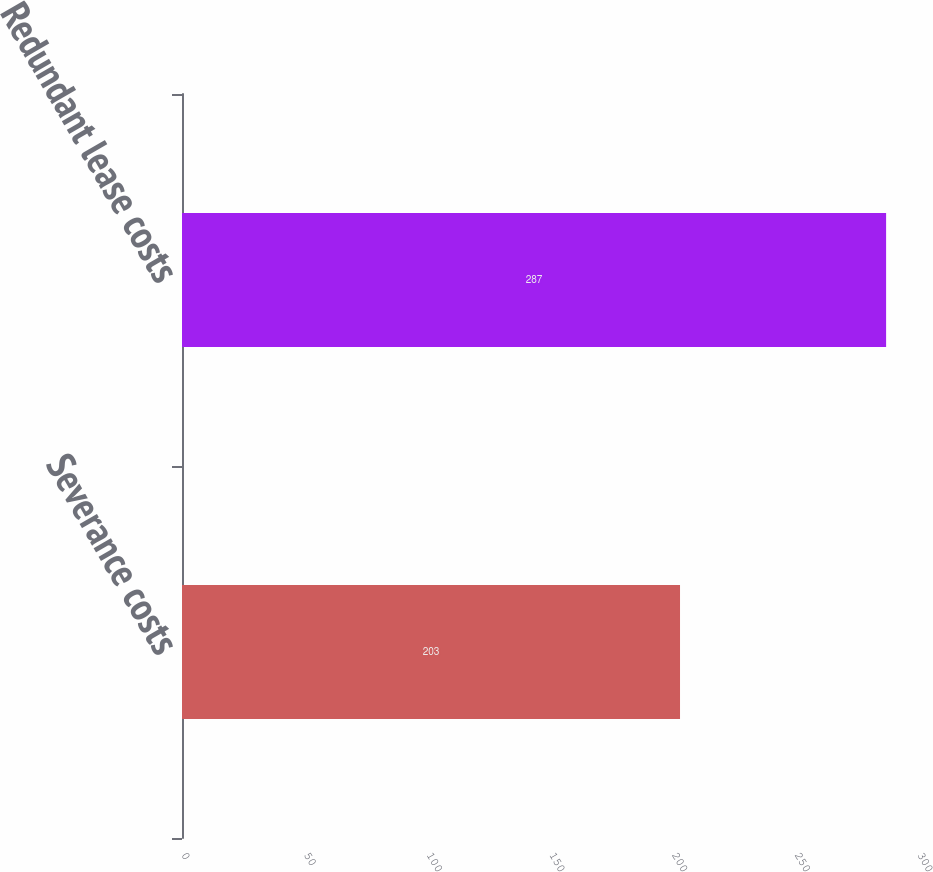Convert chart. <chart><loc_0><loc_0><loc_500><loc_500><bar_chart><fcel>Severance costs<fcel>Redundant lease costs<nl><fcel>203<fcel>287<nl></chart> 